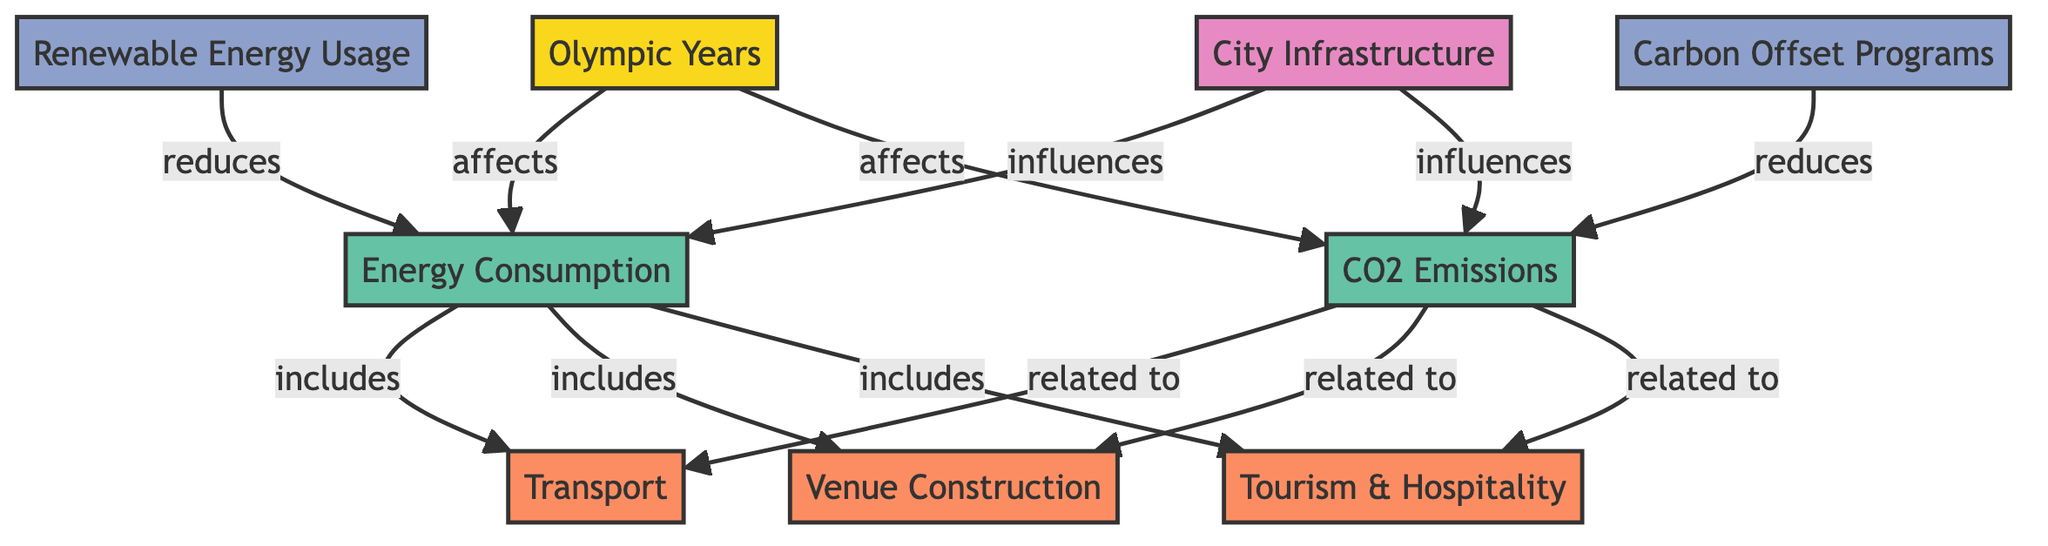What are the main contributors to energy consumption during Olympic events? The contributors listed in the diagram under the Energy Consumption node include Transport, Venue Construction, and Tourism & Hospitality. Thus, these three categories are the main contributors.
Answer: Transport, Venue Construction, Tourism & Hospitality How many mitigation strategies are presented in the diagram? The diagram shows two mitigation strategies: Carbon Offset Programs and Renewable Energy Usage. Therefore, the total count of mitigation strategies is two.
Answer: 2 What is the relationship between Olympic Years and CO2 Emissions? The diagram indicates that Olympic Years affect CO2 Emissions, as shown by the directed arrow from Olympic Years to CO2 Emissions. This establishes a clear dependency between these two nodes.
Answer: affects Which category influences both energy consumption and CO2 emissions? The City Infrastructure node influences both Energy Consumption and CO2 Emissions, as indicated in the diagram. Thus, it acts as a common influencing factor for both metrics.
Answer: City Infrastructure If Carbon Offset Programs are implemented, what effect do they have on CO2 emissions? The diagram specifies that Carbon Offset Programs reduce CO2 emissions. Thus, their implementation leads to a decrease in CO2 emissions as outlined in the diagram.
Answer: reduces How many categories are linked to energy consumption in the diagram? The Energy Consumption node has three specific contributors linked to it: Transport, Venue Construction, and Tourism & Hospitality, making a total of three categories associated with it.
Answer: 3 Which mitigation strategy is related to reducing energy consumption? The diagram connects Renewable Energy Usage to Energy Consumption, marking it as a strategy that contributes to reducing energy consumption during Olympic events.
Answer: Renewable Energy Usage How many metric nodes are present in the diagram? The diagram presents two metric nodes: Energy Consumption and CO2 Emissions. This signifies that there are a total of two metrics within the framework of the study.
Answer: 2 